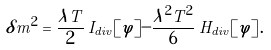<formula> <loc_0><loc_0><loc_500><loc_500>\delta m ^ { 2 } = \frac { \lambda T } { 2 } \, I _ { d i v } [ \varphi ] - \frac { \lambda ^ { 2 } T ^ { 2 } } { 6 } \, H _ { d i v } [ \varphi ] \, .</formula> 